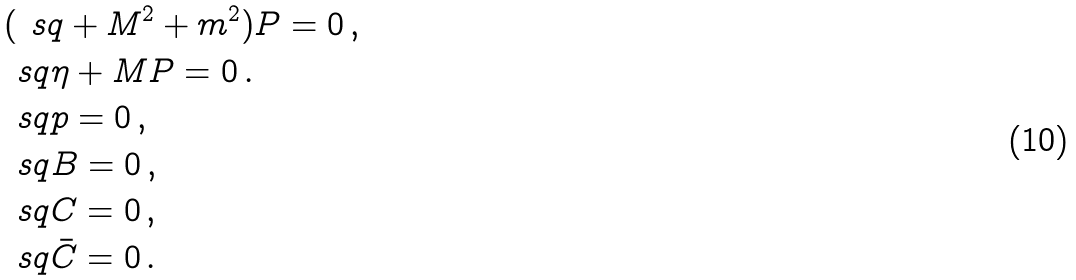<formula> <loc_0><loc_0><loc_500><loc_500>& ( \ s q + M ^ { 2 } + m ^ { 2 } ) P = 0 \, , \\ & \ s q \eta + M P = 0 \, . \\ & \ s q p = 0 \, , \\ & \ s q B = 0 \, , \\ & \ s q C = 0 \, , \\ & \ s q \bar { C } = 0 \, .</formula> 